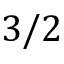<formula> <loc_0><loc_0><loc_500><loc_500>3 / 2</formula> 